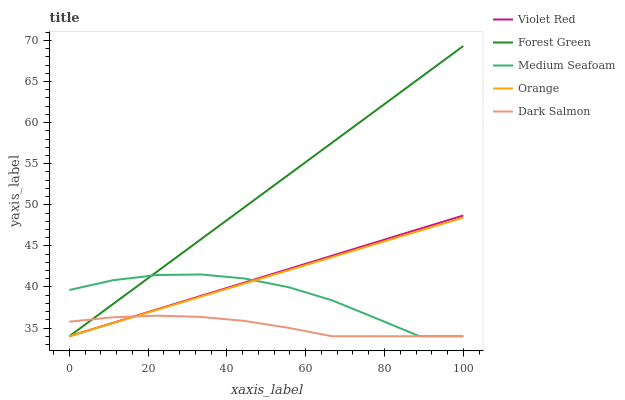Does Dark Salmon have the minimum area under the curve?
Answer yes or no. Yes. Does Forest Green have the maximum area under the curve?
Answer yes or no. Yes. Does Violet Red have the minimum area under the curve?
Answer yes or no. No. Does Violet Red have the maximum area under the curve?
Answer yes or no. No. Is Orange the smoothest?
Answer yes or no. Yes. Is Medium Seafoam the roughest?
Answer yes or no. Yes. Is Violet Red the smoothest?
Answer yes or no. No. Is Violet Red the roughest?
Answer yes or no. No. Does Orange have the lowest value?
Answer yes or no. Yes. Does Forest Green have the highest value?
Answer yes or no. Yes. Does Violet Red have the highest value?
Answer yes or no. No. Does Violet Red intersect Orange?
Answer yes or no. Yes. Is Violet Red less than Orange?
Answer yes or no. No. Is Violet Red greater than Orange?
Answer yes or no. No. 